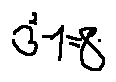Convert formula to latex. <formula><loc_0><loc_0><loc_500><loc_500>3 ^ { 2 } - 1 = 8</formula> 